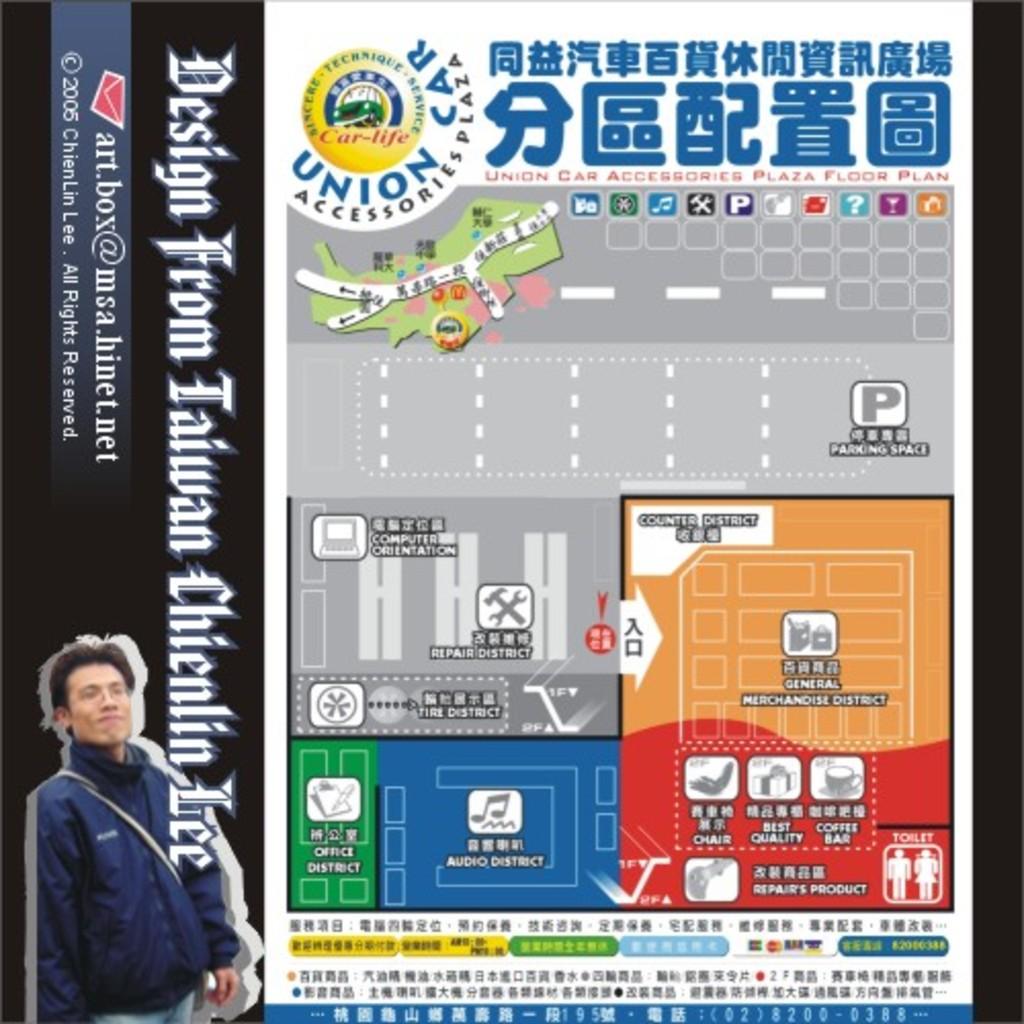What is the name of the accessories plaza?
Your answer should be compact. Union car. Who are the designs by?
Give a very brief answer. Taiwan chienlin lee. 